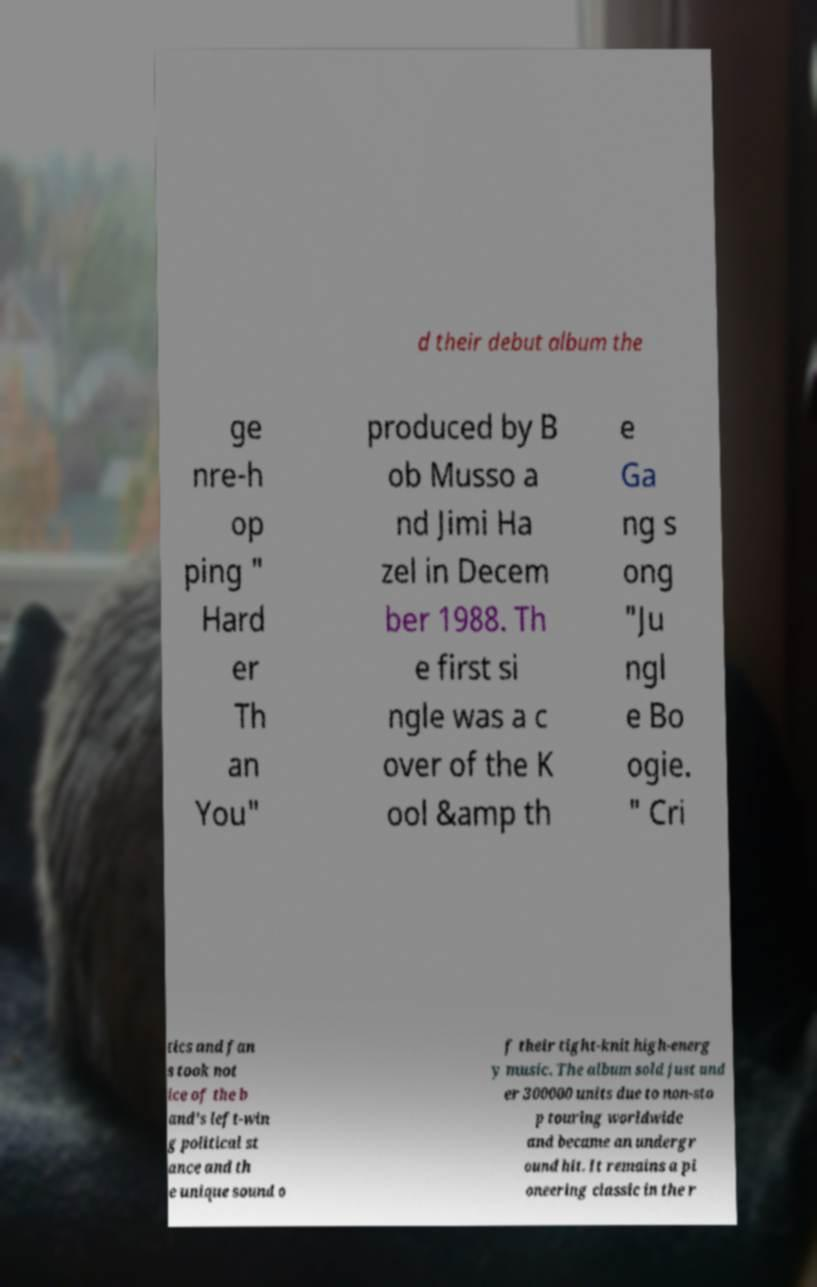Could you extract and type out the text from this image? d their debut album the ge nre-h op ping " Hard er Th an You" produced by B ob Musso a nd Jimi Ha zel in Decem ber 1988. Th e first si ngle was a c over of the K ool &amp th e Ga ng s ong "Ju ngl e Bo ogie. " Cri tics and fan s took not ice of the b and's left-win g political st ance and th e unique sound o f their tight-knit high-energ y music. The album sold just und er 300000 units due to non-sto p touring worldwide and became an undergr ound hit. It remains a pi oneering classic in the r 